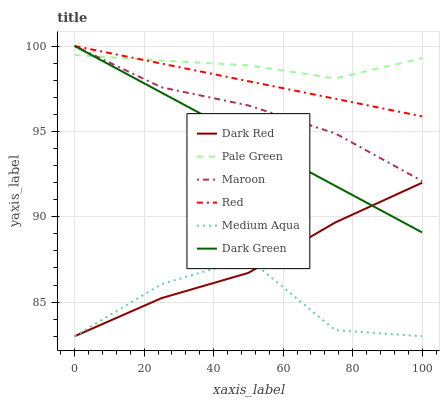Does Medium Aqua have the minimum area under the curve?
Answer yes or no. Yes. Does Pale Green have the maximum area under the curve?
Answer yes or no. Yes. Does Maroon have the minimum area under the curve?
Answer yes or no. No. Does Maroon have the maximum area under the curve?
Answer yes or no. No. Is Dark Green the smoothest?
Answer yes or no. Yes. Is Medium Aqua the roughest?
Answer yes or no. Yes. Is Maroon the smoothest?
Answer yes or no. No. Is Maroon the roughest?
Answer yes or no. No. Does Dark Red have the lowest value?
Answer yes or no. Yes. Does Maroon have the lowest value?
Answer yes or no. No. Does Dark Green have the highest value?
Answer yes or no. Yes. Does Pale Green have the highest value?
Answer yes or no. No. Is Medium Aqua less than Maroon?
Answer yes or no. Yes. Is Pale Green greater than Dark Red?
Answer yes or no. Yes. Does Maroon intersect Pale Green?
Answer yes or no. Yes. Is Maroon less than Pale Green?
Answer yes or no. No. Is Maroon greater than Pale Green?
Answer yes or no. No. Does Medium Aqua intersect Maroon?
Answer yes or no. No. 